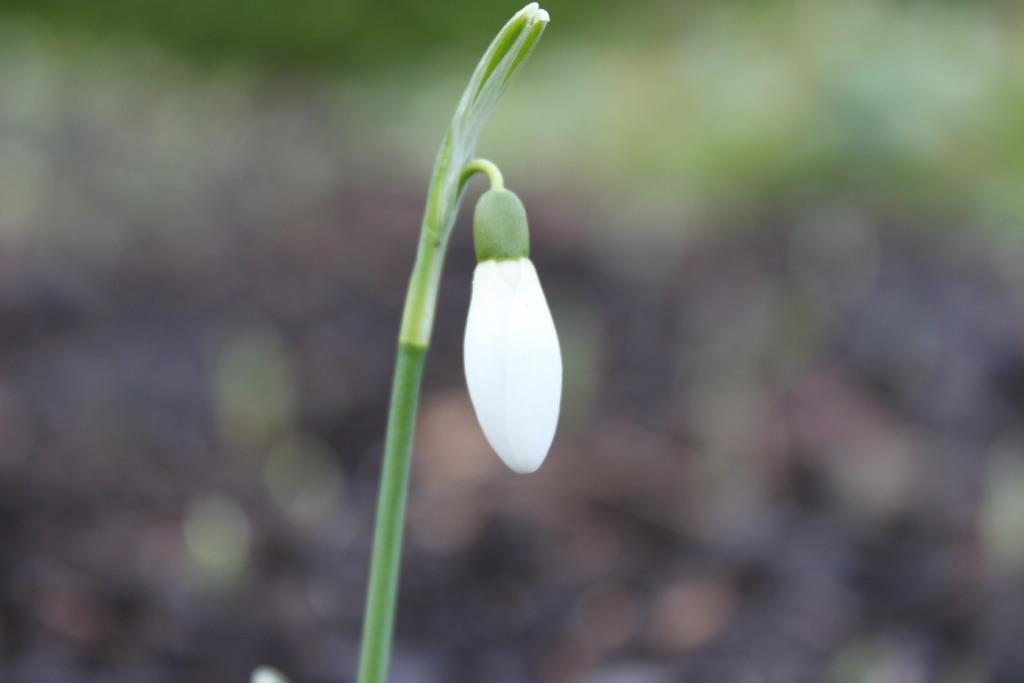Could you give a brief overview of what you see in this image? In the center of the image we can see a bug which is in white color and there is a stem. 